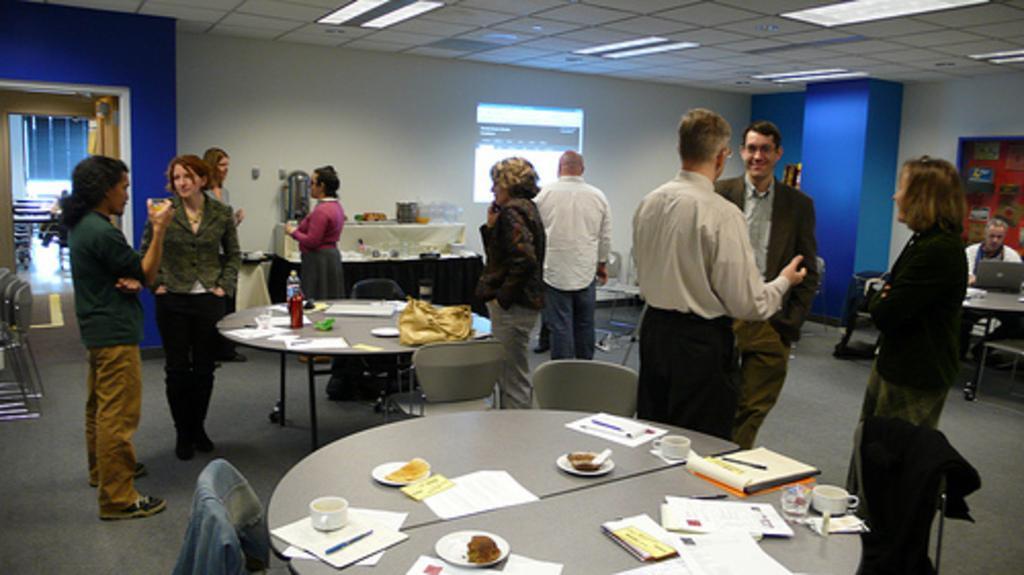Could you give a brief overview of what you see in this image? in this picture we can see group of people standing in the office room and talking to each other. We can see around grey color table on which books and files can see with tea cup and cake on the table, Beside there is woman standing wearing black coat is watching to the two person talking with each other. Other man wearing a white shirt is watch on the projector screen on the white wall. Beside there is a woman wearing a black jacket talking on the phone and yellow bag on the table, Other side we can see a woman and man talking each other and having a glass of juice. 